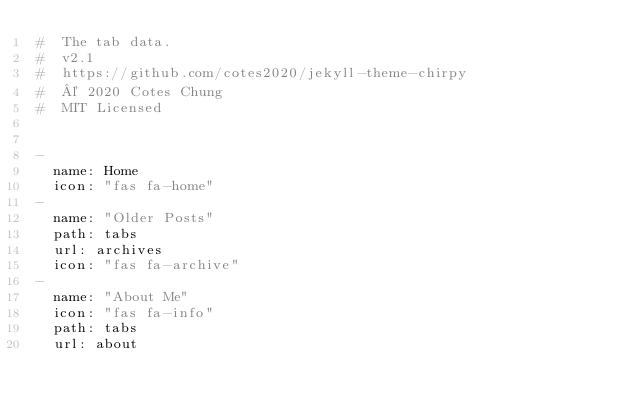<code> <loc_0><loc_0><loc_500><loc_500><_YAML_>#  The tab data.
#  v2.1
#  https://github.com/cotes2020/jekyll-theme-chirpy
#  © 2020 Cotes Chung
#  MIT Licensed


-
  name: Home
  icon: "fas fa-home"
-
  name: "Older Posts"
  path: tabs
  url: archives
  icon: "fas fa-archive"
-
  name: "About Me"
  icon: "fas fa-info"
  path: tabs
  url: about
</code> 